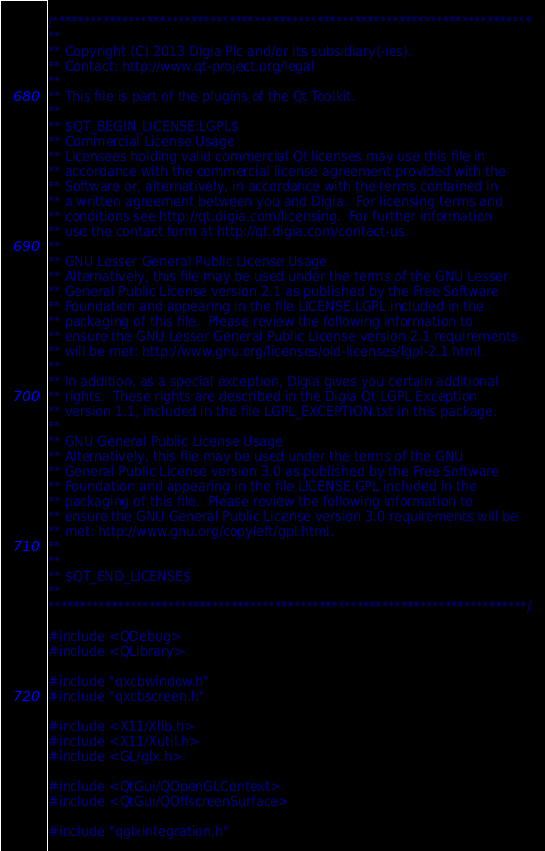<code> <loc_0><loc_0><loc_500><loc_500><_C++_>/****************************************************************************
**
** Copyright (C) 2013 Digia Plc and/or its subsidiary(-ies).
** Contact: http://www.qt-project.org/legal
**
** This file is part of the plugins of the Qt Toolkit.
**
** $QT_BEGIN_LICENSE:LGPL$
** Commercial License Usage
** Licensees holding valid commercial Qt licenses may use this file in
** accordance with the commercial license agreement provided with the
** Software or, alternatively, in accordance with the terms contained in
** a written agreement between you and Digia.  For licensing terms and
** conditions see http://qt.digia.com/licensing.  For further information
** use the contact form at http://qt.digia.com/contact-us.
**
** GNU Lesser General Public License Usage
** Alternatively, this file may be used under the terms of the GNU Lesser
** General Public License version 2.1 as published by the Free Software
** Foundation and appearing in the file LICENSE.LGPL included in the
** packaging of this file.  Please review the following information to
** ensure the GNU Lesser General Public License version 2.1 requirements
** will be met: http://www.gnu.org/licenses/old-licenses/lgpl-2.1.html.
**
** In addition, as a special exception, Digia gives you certain additional
** rights.  These rights are described in the Digia Qt LGPL Exception
** version 1.1, included in the file LGPL_EXCEPTION.txt in this package.
**
** GNU General Public License Usage
** Alternatively, this file may be used under the terms of the GNU
** General Public License version 3.0 as published by the Free Software
** Foundation and appearing in the file LICENSE.GPL included in the
** packaging of this file.  Please review the following information to
** ensure the GNU General Public License version 3.0 requirements will be
** met: http://www.gnu.org/copyleft/gpl.html.
**
**
** $QT_END_LICENSE$
**
****************************************************************************/

#include <QDebug>
#include <QLibrary>

#include "qxcbwindow.h"
#include "qxcbscreen.h"

#include <X11/Xlib.h>
#include <X11/Xutil.h>
#include <GL/glx.h>

#include <QtGui/QOpenGLContext>
#include <QtGui/QOffscreenSurface>

#include "qglxintegration.h"</code> 